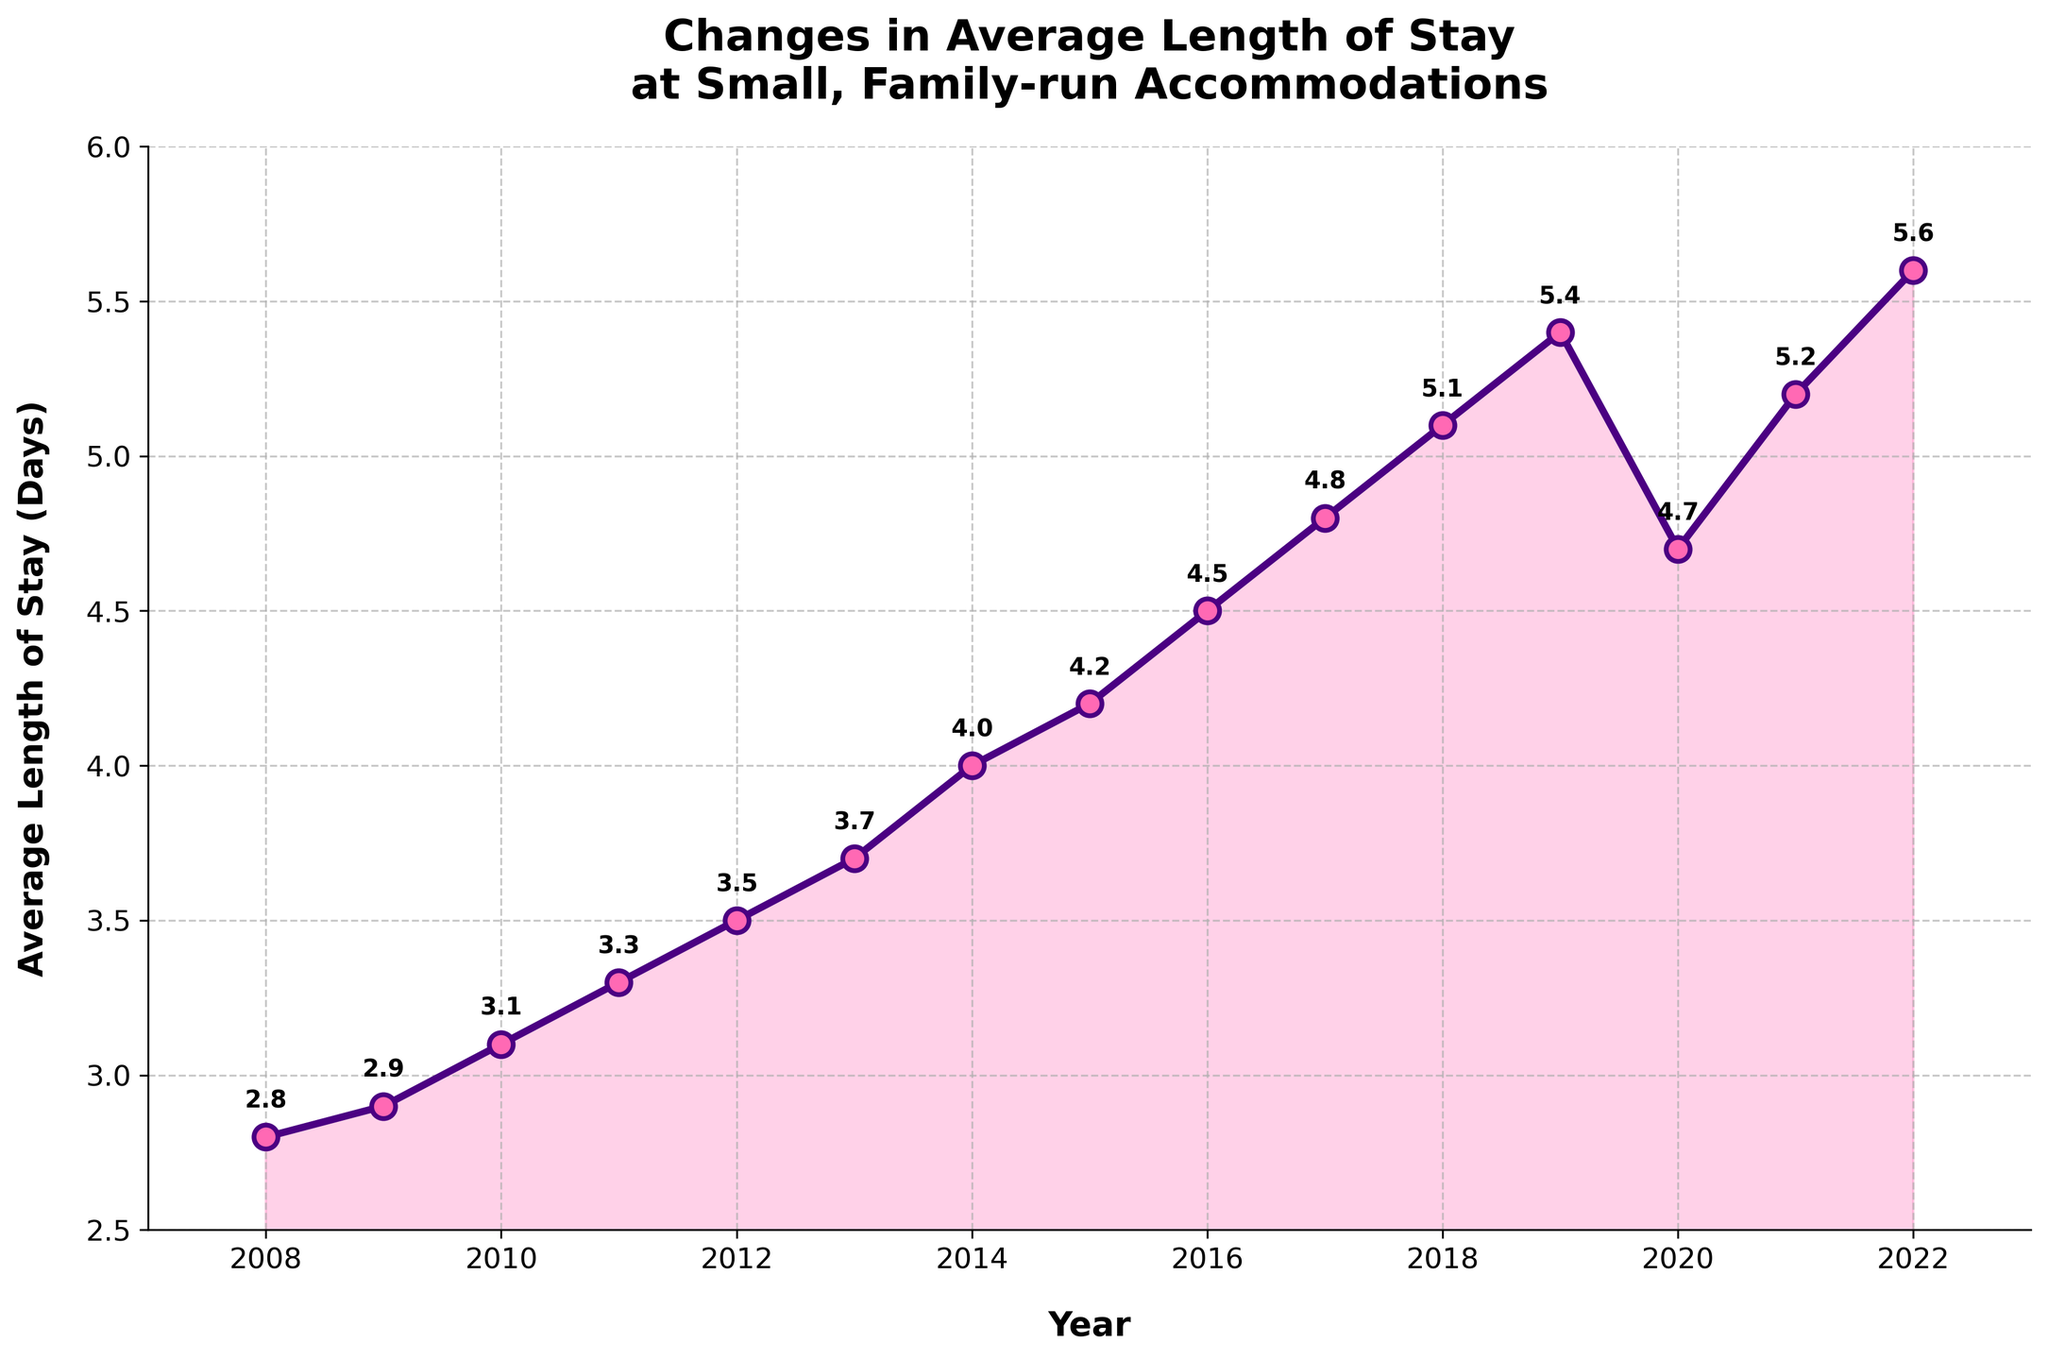What year saw the largest drop in the average length of stay? The largest drop in the average length of stay is noted between 2019 and 2020, where it decreased from 5.4 days to 4.7 days. This is a difference of 0.7 days, the largest year-to-year drop in the data.
Answer: 2020 How many times did the average length of stay increase from one year to the next? By visually inspecting the line chart, increases can be observed in all years except between 2019 to 2020. Therefore, there are 14 increases in total from 2008 to 2022.
Answer: 14 Which year had the average length of stay equal to 3.1 days? By observing the plotted points and their annotations, the average length of stay was 3.1 days in the year 2010.
Answer: 2010 What is the average length of stay across the years 2018 to 2020? The average can be computed by summing the values for the years 2018 (5.1 days), 2019 (5.4 days), and 2020 (4.7 days) and then dividing by 3. \((5.1 + 5.4 + 4.7) / 3 = 5.07\).
Answer: 5.07 days How much did the average length of stay increase from 2008 to 2012? Subtract the average length of stay in 2008 (2.8 days) from that in 2012 (3.5 days). \(3.5 - 2.8 = 0.7\) days.
Answer: 0.7 days What is the approximate rate of increase in average length of stay between 2011 and 2016? Identify the increase from 2011 (3.3 days) to 2016 (4.5 days), which is \(4.5 - 3.3 = 1.2\) days, occurring over 5 years. The rate is approximately \(1.2 / 5 = 0.24\) days per year.
Answer: 0.24 days/year Which decade saw a higher overall increase in the average length of stay: 2008-2017 or 2012-2022? Calculate the increase from 2008 (2.8 days) to 2017 (4.8 days), which is \(4.8 - 2.8 = 2\) days. Then calculate the increase from 2012 (3.5 days) to 2022 (5.6 days), which is \(5.6 - 3.5 = 2.1\) days.
Answer: 2012-2022 What is the maximum average length of stay observed in the chart? The highest value annotated on the chart is 5.6 days in the year 2022.
Answer: 5.6 days Describe the overall trend in the average length of stay from 2008 to 2022. The overall trend is an increase in the average length of stay, with a noticeable dip observed around the year 2020. This can be visually confirmed by the upward trajectory of the line except for the drop in 2020.
Answer: Increasing trend with a dip in 2020 When was the average length of stay first observed to be at least 5 days? By examining the annotated points on the graph, the average length of stay first reached 5 days in the year 2018.
Answer: 2018 